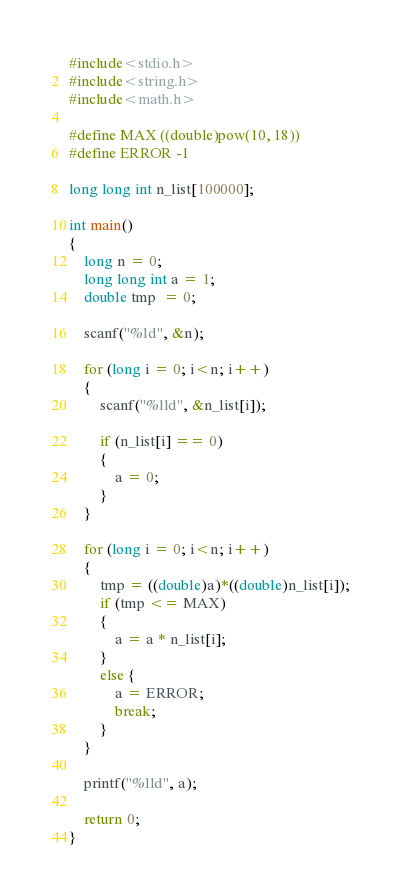Convert code to text. <code><loc_0><loc_0><loc_500><loc_500><_C_>#include<stdio.h>
#include<string.h>
#include<math.h>

#define MAX ((double)pow(10, 18))
#define ERROR -1

long long int n_list[100000];

int main()
{
	long n = 0;
	long long int a = 1;
    double tmp  = 0;

    scanf("%ld", &n);

	for (long i = 0; i<n; i++)
	{
        scanf("%lld", &n_list[i]);

		if (n_list[i] == 0)
		{
			a = 0;
		}
	}

	for (long i = 0; i<n; i++)
	{
        tmp = ((double)a)*((double)n_list[i]);
		if (tmp <= MAX)
		{
			a = a * n_list[i];
		}
		else {
			a = ERROR;
			break;
		}
	}

	printf("%lld", a);

	return 0;
}</code> 